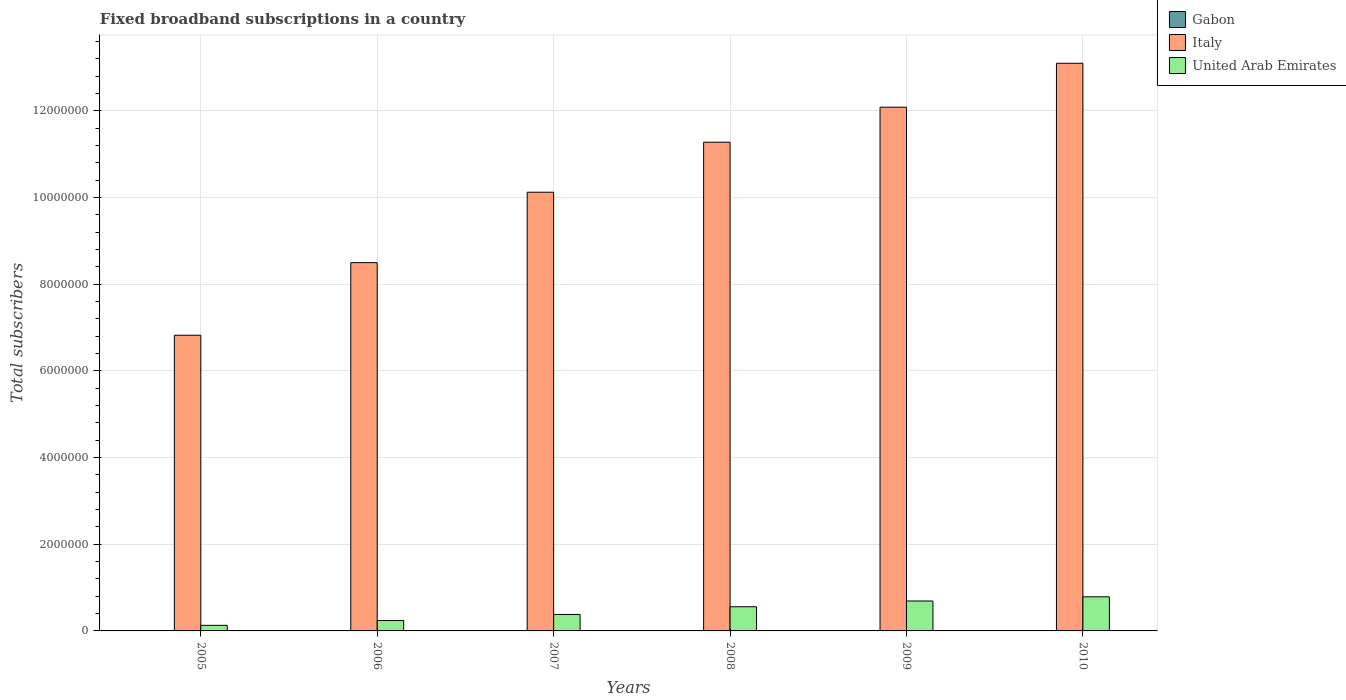Are the number of bars per tick equal to the number of legend labels?
Ensure brevity in your answer.  Yes. What is the label of the 5th group of bars from the left?
Keep it short and to the point. 2009. What is the number of broadband subscriptions in Gabon in 2005?
Offer a terse response. 1530. Across all years, what is the maximum number of broadband subscriptions in Italy?
Offer a terse response. 1.31e+07. Across all years, what is the minimum number of broadband subscriptions in United Arab Emirates?
Your answer should be compact. 1.29e+05. In which year was the number of broadband subscriptions in Gabon minimum?
Your response must be concise. 2005. What is the total number of broadband subscriptions in United Arab Emirates in the graph?
Your response must be concise. 2.78e+06. What is the difference between the number of broadband subscriptions in Gabon in 2009 and that in 2010?
Your answer should be compact. -385. What is the difference between the number of broadband subscriptions in Italy in 2010 and the number of broadband subscriptions in United Arab Emirates in 2005?
Your response must be concise. 1.30e+07. What is the average number of broadband subscriptions in Gabon per year?
Your answer should be compact. 2542.5. In the year 2006, what is the difference between the number of broadband subscriptions in Gabon and number of broadband subscriptions in United Arab Emirates?
Make the answer very short. -2.39e+05. What is the ratio of the number of broadband subscriptions in Gabon in 2006 to that in 2009?
Make the answer very short. 0.48. Is the number of broadband subscriptions in United Arab Emirates in 2008 less than that in 2010?
Offer a terse response. Yes. What is the difference between the highest and the second highest number of broadband subscriptions in Gabon?
Give a very brief answer. 385. What is the difference between the highest and the lowest number of broadband subscriptions in Italy?
Give a very brief answer. 6.28e+06. What does the 3rd bar from the right in 2005 represents?
Give a very brief answer. Gabon. Is it the case that in every year, the sum of the number of broadband subscriptions in Italy and number of broadband subscriptions in United Arab Emirates is greater than the number of broadband subscriptions in Gabon?
Keep it short and to the point. Yes. How many years are there in the graph?
Offer a terse response. 6. What is the difference between two consecutive major ticks on the Y-axis?
Offer a terse response. 2.00e+06. Are the values on the major ticks of Y-axis written in scientific E-notation?
Offer a very short reply. No. Does the graph contain any zero values?
Provide a short and direct response. No. Does the graph contain grids?
Ensure brevity in your answer.  Yes. Where does the legend appear in the graph?
Your answer should be compact. Top right. What is the title of the graph?
Offer a terse response. Fixed broadband subscriptions in a country. What is the label or title of the X-axis?
Give a very brief answer. Years. What is the label or title of the Y-axis?
Provide a short and direct response. Total subscribers. What is the Total subscribers in Gabon in 2005?
Your answer should be very brief. 1530. What is the Total subscribers in Italy in 2005?
Ensure brevity in your answer.  6.82e+06. What is the Total subscribers in United Arab Emirates in 2005?
Keep it short and to the point. 1.29e+05. What is the Total subscribers in Gabon in 2006?
Offer a terse response. 1763. What is the Total subscribers in Italy in 2006?
Keep it short and to the point. 8.50e+06. What is the Total subscribers of United Arab Emirates in 2006?
Provide a short and direct response. 2.41e+05. What is the Total subscribers of Gabon in 2007?
Your answer should be compact. 1983. What is the Total subscribers of Italy in 2007?
Provide a succinct answer. 1.01e+07. What is the Total subscribers in United Arab Emirates in 2007?
Provide a succinct answer. 3.80e+05. What is the Total subscribers of Gabon in 2008?
Your answer should be compact. 2200. What is the Total subscribers in Italy in 2008?
Your answer should be very brief. 1.13e+07. What is the Total subscribers of United Arab Emirates in 2008?
Your response must be concise. 5.58e+05. What is the Total subscribers in Gabon in 2009?
Your answer should be very brief. 3697. What is the Total subscribers of Italy in 2009?
Your answer should be very brief. 1.21e+07. What is the Total subscribers of United Arab Emirates in 2009?
Provide a short and direct response. 6.90e+05. What is the Total subscribers of Gabon in 2010?
Ensure brevity in your answer.  4082. What is the Total subscribers in Italy in 2010?
Make the answer very short. 1.31e+07. What is the Total subscribers in United Arab Emirates in 2010?
Offer a very short reply. 7.87e+05. Across all years, what is the maximum Total subscribers in Gabon?
Your answer should be compact. 4082. Across all years, what is the maximum Total subscribers of Italy?
Provide a short and direct response. 1.31e+07. Across all years, what is the maximum Total subscribers of United Arab Emirates?
Offer a terse response. 7.87e+05. Across all years, what is the minimum Total subscribers of Gabon?
Offer a terse response. 1530. Across all years, what is the minimum Total subscribers of Italy?
Provide a short and direct response. 6.82e+06. Across all years, what is the minimum Total subscribers of United Arab Emirates?
Offer a terse response. 1.29e+05. What is the total Total subscribers in Gabon in the graph?
Provide a succinct answer. 1.53e+04. What is the total Total subscribers of Italy in the graph?
Keep it short and to the point. 6.19e+07. What is the total Total subscribers in United Arab Emirates in the graph?
Your answer should be very brief. 2.78e+06. What is the difference between the Total subscribers of Gabon in 2005 and that in 2006?
Give a very brief answer. -233. What is the difference between the Total subscribers in Italy in 2005 and that in 2006?
Offer a terse response. -1.68e+06. What is the difference between the Total subscribers of United Arab Emirates in 2005 and that in 2006?
Your answer should be compact. -1.11e+05. What is the difference between the Total subscribers in Gabon in 2005 and that in 2007?
Your answer should be compact. -453. What is the difference between the Total subscribers in Italy in 2005 and that in 2007?
Your answer should be compact. -3.30e+06. What is the difference between the Total subscribers of United Arab Emirates in 2005 and that in 2007?
Your response must be concise. -2.50e+05. What is the difference between the Total subscribers in Gabon in 2005 and that in 2008?
Provide a short and direct response. -670. What is the difference between the Total subscribers in Italy in 2005 and that in 2008?
Your answer should be very brief. -4.45e+06. What is the difference between the Total subscribers of United Arab Emirates in 2005 and that in 2008?
Provide a succinct answer. -4.28e+05. What is the difference between the Total subscribers of Gabon in 2005 and that in 2009?
Your answer should be compact. -2167. What is the difference between the Total subscribers in Italy in 2005 and that in 2009?
Provide a short and direct response. -5.26e+06. What is the difference between the Total subscribers in United Arab Emirates in 2005 and that in 2009?
Your response must be concise. -5.61e+05. What is the difference between the Total subscribers in Gabon in 2005 and that in 2010?
Offer a very short reply. -2552. What is the difference between the Total subscribers in Italy in 2005 and that in 2010?
Ensure brevity in your answer.  -6.28e+06. What is the difference between the Total subscribers of United Arab Emirates in 2005 and that in 2010?
Your response must be concise. -6.57e+05. What is the difference between the Total subscribers of Gabon in 2006 and that in 2007?
Your answer should be very brief. -220. What is the difference between the Total subscribers in Italy in 2006 and that in 2007?
Your response must be concise. -1.62e+06. What is the difference between the Total subscribers of United Arab Emirates in 2006 and that in 2007?
Offer a terse response. -1.39e+05. What is the difference between the Total subscribers of Gabon in 2006 and that in 2008?
Ensure brevity in your answer.  -437. What is the difference between the Total subscribers in Italy in 2006 and that in 2008?
Provide a succinct answer. -2.78e+06. What is the difference between the Total subscribers in United Arab Emirates in 2006 and that in 2008?
Ensure brevity in your answer.  -3.17e+05. What is the difference between the Total subscribers of Gabon in 2006 and that in 2009?
Your answer should be compact. -1934. What is the difference between the Total subscribers of Italy in 2006 and that in 2009?
Provide a succinct answer. -3.59e+06. What is the difference between the Total subscribers in United Arab Emirates in 2006 and that in 2009?
Provide a short and direct response. -4.50e+05. What is the difference between the Total subscribers in Gabon in 2006 and that in 2010?
Offer a terse response. -2319. What is the difference between the Total subscribers in Italy in 2006 and that in 2010?
Make the answer very short. -4.60e+06. What is the difference between the Total subscribers of United Arab Emirates in 2006 and that in 2010?
Give a very brief answer. -5.46e+05. What is the difference between the Total subscribers in Gabon in 2007 and that in 2008?
Make the answer very short. -217. What is the difference between the Total subscribers of Italy in 2007 and that in 2008?
Your response must be concise. -1.15e+06. What is the difference between the Total subscribers of United Arab Emirates in 2007 and that in 2008?
Your response must be concise. -1.78e+05. What is the difference between the Total subscribers in Gabon in 2007 and that in 2009?
Your response must be concise. -1714. What is the difference between the Total subscribers in Italy in 2007 and that in 2009?
Keep it short and to the point. -1.96e+06. What is the difference between the Total subscribers of United Arab Emirates in 2007 and that in 2009?
Provide a short and direct response. -3.11e+05. What is the difference between the Total subscribers in Gabon in 2007 and that in 2010?
Your answer should be compact. -2099. What is the difference between the Total subscribers of Italy in 2007 and that in 2010?
Offer a very short reply. -2.98e+06. What is the difference between the Total subscribers in United Arab Emirates in 2007 and that in 2010?
Offer a very short reply. -4.07e+05. What is the difference between the Total subscribers in Gabon in 2008 and that in 2009?
Offer a terse response. -1497. What is the difference between the Total subscribers of Italy in 2008 and that in 2009?
Keep it short and to the point. -8.08e+05. What is the difference between the Total subscribers in United Arab Emirates in 2008 and that in 2009?
Your response must be concise. -1.33e+05. What is the difference between the Total subscribers of Gabon in 2008 and that in 2010?
Offer a very short reply. -1882. What is the difference between the Total subscribers in Italy in 2008 and that in 2010?
Provide a succinct answer. -1.82e+06. What is the difference between the Total subscribers of United Arab Emirates in 2008 and that in 2010?
Keep it short and to the point. -2.29e+05. What is the difference between the Total subscribers in Gabon in 2009 and that in 2010?
Provide a short and direct response. -385. What is the difference between the Total subscribers of Italy in 2009 and that in 2010?
Offer a very short reply. -1.01e+06. What is the difference between the Total subscribers of United Arab Emirates in 2009 and that in 2010?
Make the answer very short. -9.64e+04. What is the difference between the Total subscribers in Gabon in 2005 and the Total subscribers in Italy in 2006?
Your response must be concise. -8.50e+06. What is the difference between the Total subscribers in Gabon in 2005 and the Total subscribers in United Arab Emirates in 2006?
Provide a short and direct response. -2.39e+05. What is the difference between the Total subscribers in Italy in 2005 and the Total subscribers in United Arab Emirates in 2006?
Your answer should be compact. 6.58e+06. What is the difference between the Total subscribers in Gabon in 2005 and the Total subscribers in Italy in 2007?
Make the answer very short. -1.01e+07. What is the difference between the Total subscribers of Gabon in 2005 and the Total subscribers of United Arab Emirates in 2007?
Give a very brief answer. -3.78e+05. What is the difference between the Total subscribers of Italy in 2005 and the Total subscribers of United Arab Emirates in 2007?
Offer a terse response. 6.44e+06. What is the difference between the Total subscribers in Gabon in 2005 and the Total subscribers in Italy in 2008?
Your answer should be compact. -1.13e+07. What is the difference between the Total subscribers of Gabon in 2005 and the Total subscribers of United Arab Emirates in 2008?
Provide a short and direct response. -5.56e+05. What is the difference between the Total subscribers of Italy in 2005 and the Total subscribers of United Arab Emirates in 2008?
Your response must be concise. 6.26e+06. What is the difference between the Total subscribers of Gabon in 2005 and the Total subscribers of Italy in 2009?
Provide a short and direct response. -1.21e+07. What is the difference between the Total subscribers of Gabon in 2005 and the Total subscribers of United Arab Emirates in 2009?
Your response must be concise. -6.89e+05. What is the difference between the Total subscribers of Italy in 2005 and the Total subscribers of United Arab Emirates in 2009?
Provide a succinct answer. 6.13e+06. What is the difference between the Total subscribers in Gabon in 2005 and the Total subscribers in Italy in 2010?
Keep it short and to the point. -1.31e+07. What is the difference between the Total subscribers of Gabon in 2005 and the Total subscribers of United Arab Emirates in 2010?
Offer a terse response. -7.85e+05. What is the difference between the Total subscribers in Italy in 2005 and the Total subscribers in United Arab Emirates in 2010?
Provide a succinct answer. 6.04e+06. What is the difference between the Total subscribers in Gabon in 2006 and the Total subscribers in Italy in 2007?
Give a very brief answer. -1.01e+07. What is the difference between the Total subscribers in Gabon in 2006 and the Total subscribers in United Arab Emirates in 2007?
Your answer should be very brief. -3.78e+05. What is the difference between the Total subscribers in Italy in 2006 and the Total subscribers in United Arab Emirates in 2007?
Your response must be concise. 8.12e+06. What is the difference between the Total subscribers in Gabon in 2006 and the Total subscribers in Italy in 2008?
Your answer should be compact. -1.13e+07. What is the difference between the Total subscribers in Gabon in 2006 and the Total subscribers in United Arab Emirates in 2008?
Your answer should be very brief. -5.56e+05. What is the difference between the Total subscribers of Italy in 2006 and the Total subscribers of United Arab Emirates in 2008?
Offer a terse response. 7.94e+06. What is the difference between the Total subscribers in Gabon in 2006 and the Total subscribers in Italy in 2009?
Your answer should be compact. -1.21e+07. What is the difference between the Total subscribers of Gabon in 2006 and the Total subscribers of United Arab Emirates in 2009?
Make the answer very short. -6.89e+05. What is the difference between the Total subscribers in Italy in 2006 and the Total subscribers in United Arab Emirates in 2009?
Provide a succinct answer. 7.81e+06. What is the difference between the Total subscribers in Gabon in 2006 and the Total subscribers in Italy in 2010?
Provide a succinct answer. -1.31e+07. What is the difference between the Total subscribers in Gabon in 2006 and the Total subscribers in United Arab Emirates in 2010?
Your response must be concise. -7.85e+05. What is the difference between the Total subscribers in Italy in 2006 and the Total subscribers in United Arab Emirates in 2010?
Give a very brief answer. 7.71e+06. What is the difference between the Total subscribers of Gabon in 2007 and the Total subscribers of Italy in 2008?
Keep it short and to the point. -1.13e+07. What is the difference between the Total subscribers of Gabon in 2007 and the Total subscribers of United Arab Emirates in 2008?
Your answer should be very brief. -5.56e+05. What is the difference between the Total subscribers in Italy in 2007 and the Total subscribers in United Arab Emirates in 2008?
Your response must be concise. 9.56e+06. What is the difference between the Total subscribers of Gabon in 2007 and the Total subscribers of Italy in 2009?
Your answer should be very brief. -1.21e+07. What is the difference between the Total subscribers in Gabon in 2007 and the Total subscribers in United Arab Emirates in 2009?
Your answer should be compact. -6.88e+05. What is the difference between the Total subscribers of Italy in 2007 and the Total subscribers of United Arab Emirates in 2009?
Provide a succinct answer. 9.43e+06. What is the difference between the Total subscribers of Gabon in 2007 and the Total subscribers of Italy in 2010?
Ensure brevity in your answer.  -1.31e+07. What is the difference between the Total subscribers in Gabon in 2007 and the Total subscribers in United Arab Emirates in 2010?
Provide a succinct answer. -7.85e+05. What is the difference between the Total subscribers in Italy in 2007 and the Total subscribers in United Arab Emirates in 2010?
Keep it short and to the point. 9.34e+06. What is the difference between the Total subscribers of Gabon in 2008 and the Total subscribers of Italy in 2009?
Provide a succinct answer. -1.21e+07. What is the difference between the Total subscribers in Gabon in 2008 and the Total subscribers in United Arab Emirates in 2009?
Make the answer very short. -6.88e+05. What is the difference between the Total subscribers in Italy in 2008 and the Total subscribers in United Arab Emirates in 2009?
Ensure brevity in your answer.  1.06e+07. What is the difference between the Total subscribers in Gabon in 2008 and the Total subscribers in Italy in 2010?
Your answer should be compact. -1.31e+07. What is the difference between the Total subscribers of Gabon in 2008 and the Total subscribers of United Arab Emirates in 2010?
Keep it short and to the point. -7.85e+05. What is the difference between the Total subscribers of Italy in 2008 and the Total subscribers of United Arab Emirates in 2010?
Your answer should be very brief. 1.05e+07. What is the difference between the Total subscribers in Gabon in 2009 and the Total subscribers in Italy in 2010?
Give a very brief answer. -1.31e+07. What is the difference between the Total subscribers in Gabon in 2009 and the Total subscribers in United Arab Emirates in 2010?
Ensure brevity in your answer.  -7.83e+05. What is the difference between the Total subscribers of Italy in 2009 and the Total subscribers of United Arab Emirates in 2010?
Provide a succinct answer. 1.13e+07. What is the average Total subscribers in Gabon per year?
Offer a very short reply. 2542.5. What is the average Total subscribers in Italy per year?
Make the answer very short. 1.03e+07. What is the average Total subscribers of United Arab Emirates per year?
Keep it short and to the point. 4.64e+05. In the year 2005, what is the difference between the Total subscribers in Gabon and Total subscribers in Italy?
Provide a short and direct response. -6.82e+06. In the year 2005, what is the difference between the Total subscribers of Gabon and Total subscribers of United Arab Emirates?
Provide a short and direct response. -1.28e+05. In the year 2005, what is the difference between the Total subscribers in Italy and Total subscribers in United Arab Emirates?
Your answer should be very brief. 6.69e+06. In the year 2006, what is the difference between the Total subscribers in Gabon and Total subscribers in Italy?
Provide a short and direct response. -8.50e+06. In the year 2006, what is the difference between the Total subscribers in Gabon and Total subscribers in United Arab Emirates?
Your answer should be very brief. -2.39e+05. In the year 2006, what is the difference between the Total subscribers of Italy and Total subscribers of United Arab Emirates?
Offer a very short reply. 8.26e+06. In the year 2007, what is the difference between the Total subscribers in Gabon and Total subscribers in Italy?
Give a very brief answer. -1.01e+07. In the year 2007, what is the difference between the Total subscribers in Gabon and Total subscribers in United Arab Emirates?
Give a very brief answer. -3.78e+05. In the year 2007, what is the difference between the Total subscribers of Italy and Total subscribers of United Arab Emirates?
Keep it short and to the point. 9.74e+06. In the year 2008, what is the difference between the Total subscribers in Gabon and Total subscribers in Italy?
Keep it short and to the point. -1.13e+07. In the year 2008, what is the difference between the Total subscribers in Gabon and Total subscribers in United Arab Emirates?
Make the answer very short. -5.55e+05. In the year 2008, what is the difference between the Total subscribers in Italy and Total subscribers in United Arab Emirates?
Keep it short and to the point. 1.07e+07. In the year 2009, what is the difference between the Total subscribers of Gabon and Total subscribers of Italy?
Your answer should be compact. -1.21e+07. In the year 2009, what is the difference between the Total subscribers of Gabon and Total subscribers of United Arab Emirates?
Ensure brevity in your answer.  -6.87e+05. In the year 2009, what is the difference between the Total subscribers in Italy and Total subscribers in United Arab Emirates?
Provide a succinct answer. 1.14e+07. In the year 2010, what is the difference between the Total subscribers of Gabon and Total subscribers of Italy?
Keep it short and to the point. -1.31e+07. In the year 2010, what is the difference between the Total subscribers of Gabon and Total subscribers of United Arab Emirates?
Ensure brevity in your answer.  -7.83e+05. In the year 2010, what is the difference between the Total subscribers in Italy and Total subscribers in United Arab Emirates?
Provide a short and direct response. 1.23e+07. What is the ratio of the Total subscribers in Gabon in 2005 to that in 2006?
Give a very brief answer. 0.87. What is the ratio of the Total subscribers in Italy in 2005 to that in 2006?
Provide a short and direct response. 0.8. What is the ratio of the Total subscribers of United Arab Emirates in 2005 to that in 2006?
Provide a succinct answer. 0.54. What is the ratio of the Total subscribers of Gabon in 2005 to that in 2007?
Your answer should be very brief. 0.77. What is the ratio of the Total subscribers in Italy in 2005 to that in 2007?
Keep it short and to the point. 0.67. What is the ratio of the Total subscribers of United Arab Emirates in 2005 to that in 2007?
Your answer should be very brief. 0.34. What is the ratio of the Total subscribers of Gabon in 2005 to that in 2008?
Give a very brief answer. 0.7. What is the ratio of the Total subscribers of Italy in 2005 to that in 2008?
Make the answer very short. 0.6. What is the ratio of the Total subscribers of United Arab Emirates in 2005 to that in 2008?
Offer a terse response. 0.23. What is the ratio of the Total subscribers of Gabon in 2005 to that in 2009?
Offer a terse response. 0.41. What is the ratio of the Total subscribers in Italy in 2005 to that in 2009?
Provide a succinct answer. 0.56. What is the ratio of the Total subscribers in United Arab Emirates in 2005 to that in 2009?
Offer a terse response. 0.19. What is the ratio of the Total subscribers in Gabon in 2005 to that in 2010?
Your answer should be very brief. 0.37. What is the ratio of the Total subscribers in Italy in 2005 to that in 2010?
Make the answer very short. 0.52. What is the ratio of the Total subscribers in United Arab Emirates in 2005 to that in 2010?
Provide a short and direct response. 0.16. What is the ratio of the Total subscribers in Gabon in 2006 to that in 2007?
Give a very brief answer. 0.89. What is the ratio of the Total subscribers of Italy in 2006 to that in 2007?
Offer a terse response. 0.84. What is the ratio of the Total subscribers of United Arab Emirates in 2006 to that in 2007?
Offer a terse response. 0.63. What is the ratio of the Total subscribers in Gabon in 2006 to that in 2008?
Your answer should be very brief. 0.8. What is the ratio of the Total subscribers in Italy in 2006 to that in 2008?
Offer a very short reply. 0.75. What is the ratio of the Total subscribers in United Arab Emirates in 2006 to that in 2008?
Offer a very short reply. 0.43. What is the ratio of the Total subscribers of Gabon in 2006 to that in 2009?
Your answer should be compact. 0.48. What is the ratio of the Total subscribers of Italy in 2006 to that in 2009?
Give a very brief answer. 0.7. What is the ratio of the Total subscribers of United Arab Emirates in 2006 to that in 2009?
Provide a succinct answer. 0.35. What is the ratio of the Total subscribers of Gabon in 2006 to that in 2010?
Your response must be concise. 0.43. What is the ratio of the Total subscribers of Italy in 2006 to that in 2010?
Offer a terse response. 0.65. What is the ratio of the Total subscribers in United Arab Emirates in 2006 to that in 2010?
Your answer should be compact. 0.31. What is the ratio of the Total subscribers of Gabon in 2007 to that in 2008?
Provide a succinct answer. 0.9. What is the ratio of the Total subscribers of Italy in 2007 to that in 2008?
Provide a short and direct response. 0.9. What is the ratio of the Total subscribers in United Arab Emirates in 2007 to that in 2008?
Keep it short and to the point. 0.68. What is the ratio of the Total subscribers of Gabon in 2007 to that in 2009?
Keep it short and to the point. 0.54. What is the ratio of the Total subscribers in Italy in 2007 to that in 2009?
Offer a very short reply. 0.84. What is the ratio of the Total subscribers in United Arab Emirates in 2007 to that in 2009?
Your response must be concise. 0.55. What is the ratio of the Total subscribers in Gabon in 2007 to that in 2010?
Ensure brevity in your answer.  0.49. What is the ratio of the Total subscribers of Italy in 2007 to that in 2010?
Provide a succinct answer. 0.77. What is the ratio of the Total subscribers in United Arab Emirates in 2007 to that in 2010?
Your answer should be very brief. 0.48. What is the ratio of the Total subscribers of Gabon in 2008 to that in 2009?
Provide a short and direct response. 0.6. What is the ratio of the Total subscribers of Italy in 2008 to that in 2009?
Your answer should be compact. 0.93. What is the ratio of the Total subscribers of United Arab Emirates in 2008 to that in 2009?
Ensure brevity in your answer.  0.81. What is the ratio of the Total subscribers of Gabon in 2008 to that in 2010?
Offer a terse response. 0.54. What is the ratio of the Total subscribers of Italy in 2008 to that in 2010?
Your answer should be compact. 0.86. What is the ratio of the Total subscribers of United Arab Emirates in 2008 to that in 2010?
Keep it short and to the point. 0.71. What is the ratio of the Total subscribers in Gabon in 2009 to that in 2010?
Offer a very short reply. 0.91. What is the ratio of the Total subscribers of Italy in 2009 to that in 2010?
Your answer should be very brief. 0.92. What is the ratio of the Total subscribers of United Arab Emirates in 2009 to that in 2010?
Keep it short and to the point. 0.88. What is the difference between the highest and the second highest Total subscribers in Gabon?
Keep it short and to the point. 385. What is the difference between the highest and the second highest Total subscribers in Italy?
Offer a very short reply. 1.01e+06. What is the difference between the highest and the second highest Total subscribers in United Arab Emirates?
Keep it short and to the point. 9.64e+04. What is the difference between the highest and the lowest Total subscribers of Gabon?
Give a very brief answer. 2552. What is the difference between the highest and the lowest Total subscribers in Italy?
Give a very brief answer. 6.28e+06. What is the difference between the highest and the lowest Total subscribers in United Arab Emirates?
Provide a short and direct response. 6.57e+05. 